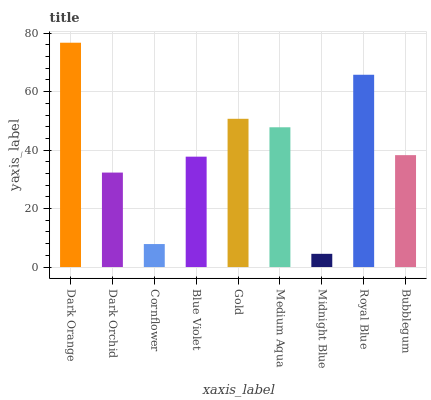Is Midnight Blue the minimum?
Answer yes or no. Yes. Is Dark Orange the maximum?
Answer yes or no. Yes. Is Dark Orchid the minimum?
Answer yes or no. No. Is Dark Orchid the maximum?
Answer yes or no. No. Is Dark Orange greater than Dark Orchid?
Answer yes or no. Yes. Is Dark Orchid less than Dark Orange?
Answer yes or no. Yes. Is Dark Orchid greater than Dark Orange?
Answer yes or no. No. Is Dark Orange less than Dark Orchid?
Answer yes or no. No. Is Bubblegum the high median?
Answer yes or no. Yes. Is Bubblegum the low median?
Answer yes or no. Yes. Is Blue Violet the high median?
Answer yes or no. No. Is Dark Orange the low median?
Answer yes or no. No. 